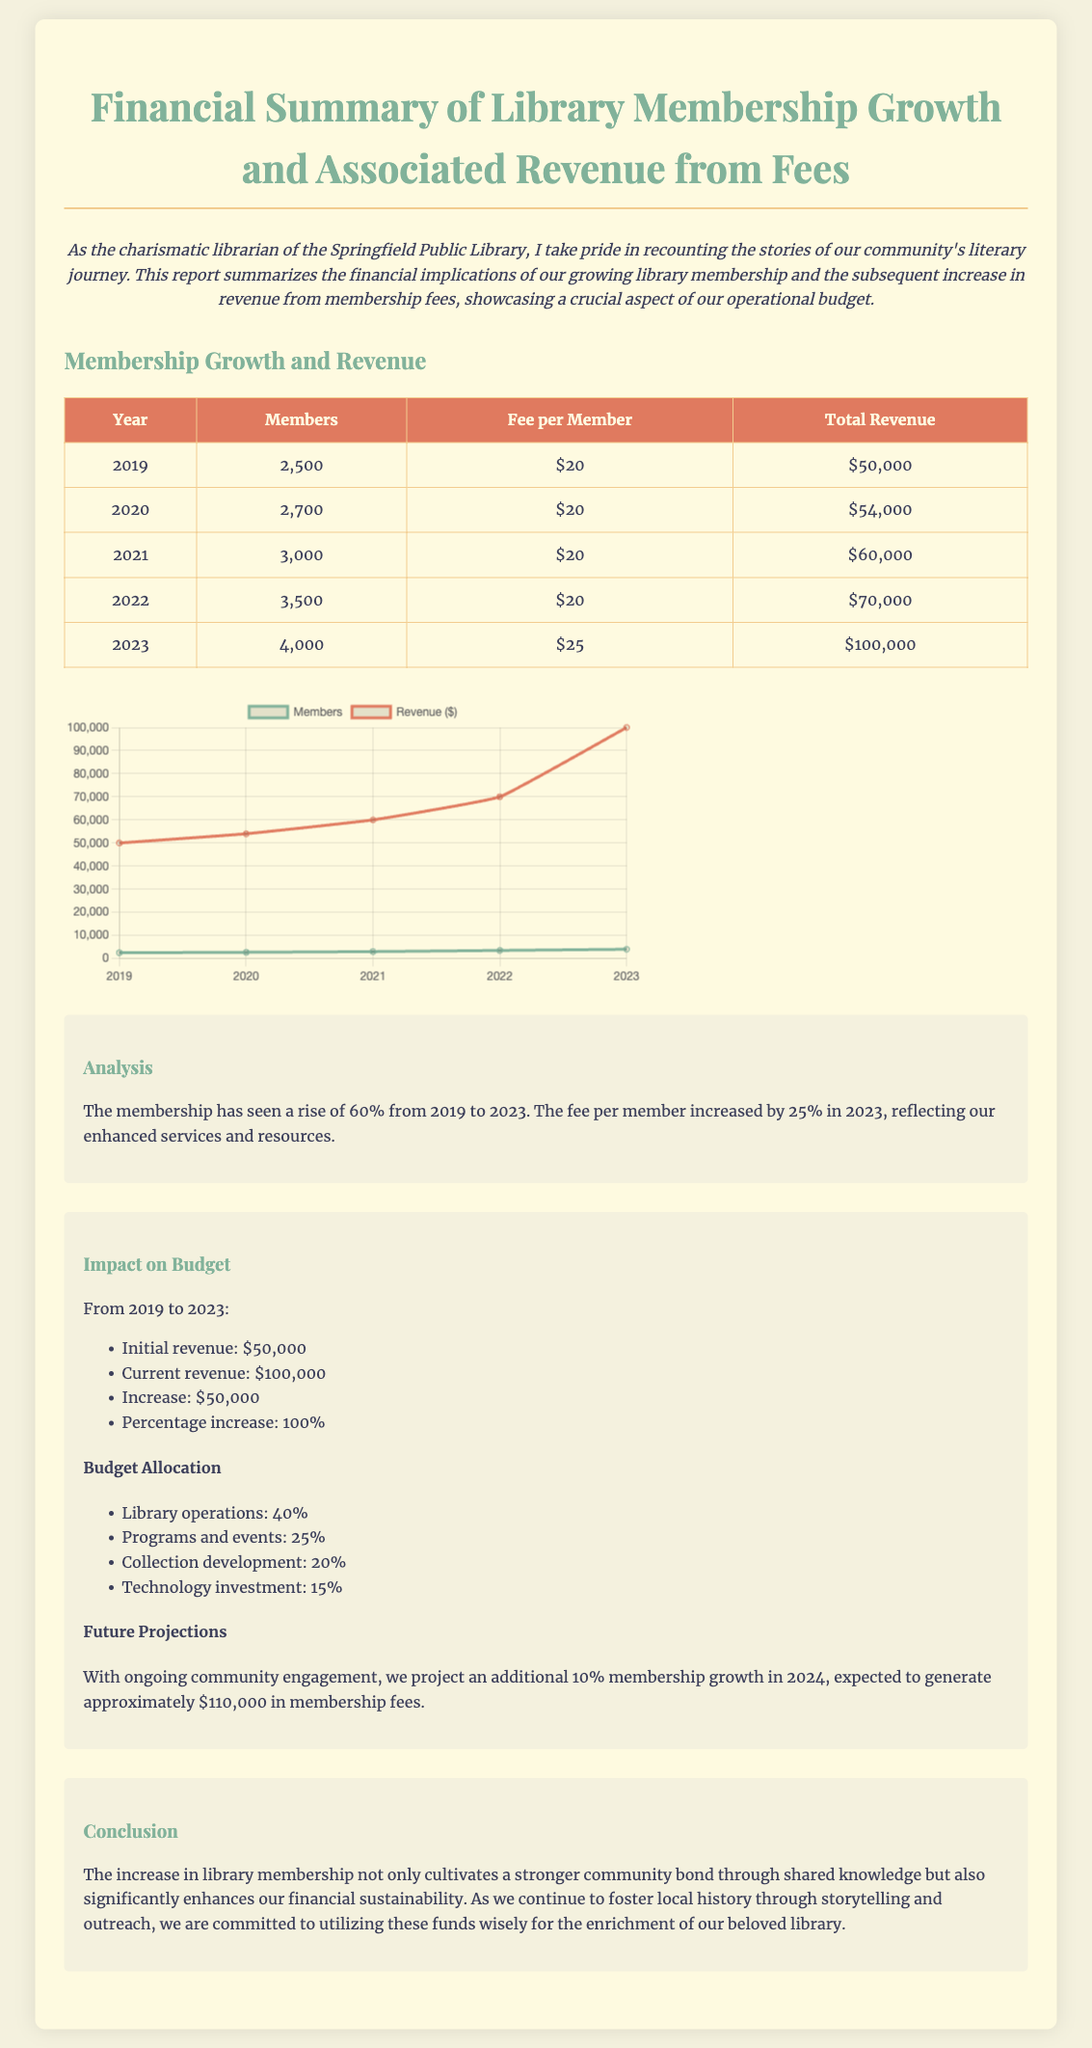What was the membership number in 2022? The membership number for the year 2022 is provided in the table under the 'Members' column.
Answer: 3,500 What is the fee per member in 2023? The fee per member for 2023 is listed in the 'Fee per Member' column of the table.
Answer: $25 How much total revenue did the library generate in 2021? The total revenue for 2021 is shown in the 'Total Revenue' column of the table.
Answer: $60,000 What is the percentage increase in revenue from 2019 to 2023? The document states that the revenue increased from $50,000 to $100,000, indicating a 100% increase.
Answer: 100% What is the projected membership growth for 2024? The report mentions a projection of an additional 10% membership growth for the year 2024.
Answer: 10% How much of the budget is allocated to library operations? The document lists budget allocation percentages in the section on 'Budget Allocation'.
Answer: 40% How many members were there in the library in 2020? The document provides the membership number for the year 2020 in the corresponding row of the table.
Answer: 2,700 What is the total revenue for 2022? The total revenue for 2022 is indicated in the table under the 'Total Revenue' column.
Answer: $70,000 What was the initial revenue in 2019? The initial revenue for 2019 is presented in the 'Total Revenue' column of the table.
Answer: $50,000 